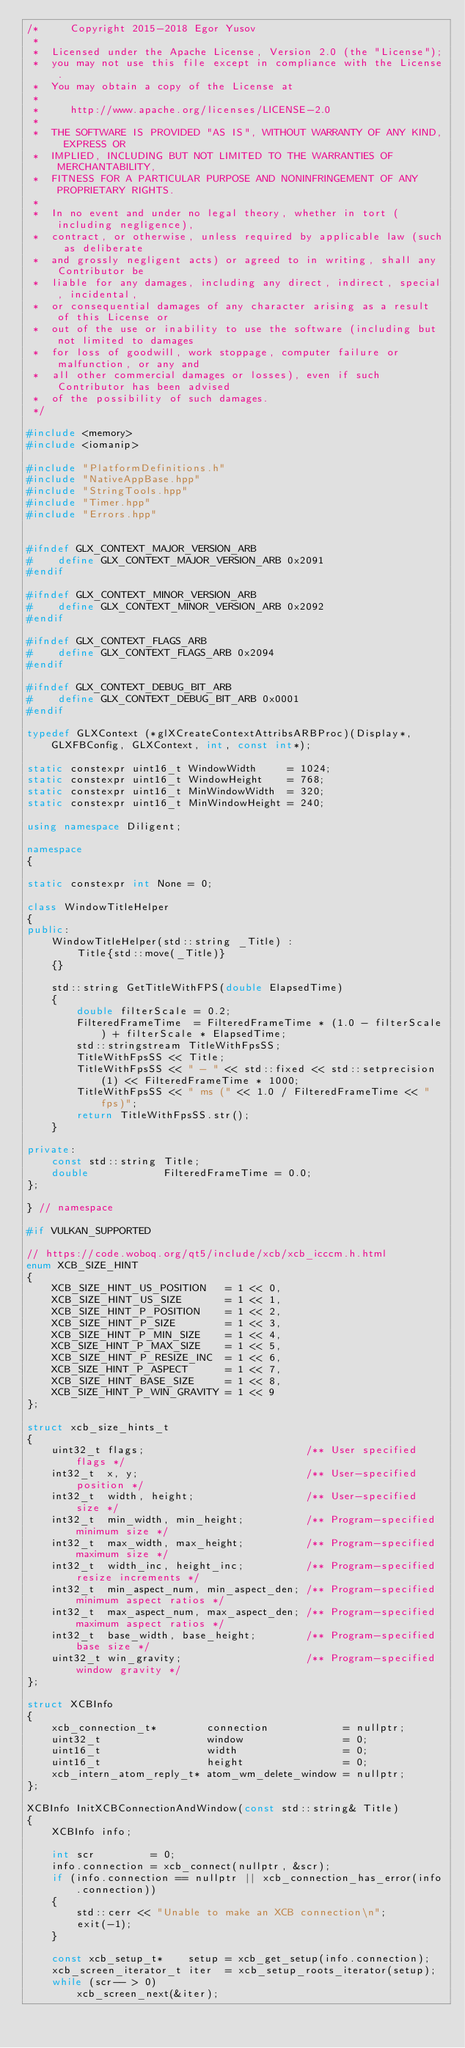Convert code to text. <code><loc_0><loc_0><loc_500><loc_500><_C++_>/*     Copyright 2015-2018 Egor Yusov
 *  
 *  Licensed under the Apache License, Version 2.0 (the "License");
 *  you may not use this file except in compliance with the License.
 *  You may obtain a copy of the License at
 * 
 *     http://www.apache.org/licenses/LICENSE-2.0
 * 
 *  THE SOFTWARE IS PROVIDED "AS IS", WITHOUT WARRANTY OF ANY KIND, EXPRESS OR
 *  IMPLIED, INCLUDING BUT NOT LIMITED TO THE WARRANTIES OF MERCHANTABILITY,
 *  FITNESS FOR A PARTICULAR PURPOSE AND NONINFRINGEMENT OF ANY PROPRIETARY RIGHTS.
 *
 *  In no event and under no legal theory, whether in tort (including negligence), 
 *  contract, or otherwise, unless required by applicable law (such as deliberate 
 *  and grossly negligent acts) or agreed to in writing, shall any Contributor be
 *  liable for any damages, including any direct, indirect, special, incidental, 
 *  or consequential damages of any character arising as a result of this License or 
 *  out of the use or inability to use the software (including but not limited to damages 
 *  for loss of goodwill, work stoppage, computer failure or malfunction, or any and 
 *  all other commercial damages or losses), even if such Contributor has been advised 
 *  of the possibility of such damages.
 */

#include <memory>
#include <iomanip>

#include "PlatformDefinitions.h"
#include "NativeAppBase.hpp"
#include "StringTools.hpp"
#include "Timer.hpp"
#include "Errors.hpp"


#ifndef GLX_CONTEXT_MAJOR_VERSION_ARB
#    define GLX_CONTEXT_MAJOR_VERSION_ARB 0x2091
#endif

#ifndef GLX_CONTEXT_MINOR_VERSION_ARB
#    define GLX_CONTEXT_MINOR_VERSION_ARB 0x2092
#endif

#ifndef GLX_CONTEXT_FLAGS_ARB
#    define GLX_CONTEXT_FLAGS_ARB 0x2094
#endif

#ifndef GLX_CONTEXT_DEBUG_BIT_ARB
#    define GLX_CONTEXT_DEBUG_BIT_ARB 0x0001
#endif

typedef GLXContext (*glXCreateContextAttribsARBProc)(Display*, GLXFBConfig, GLXContext, int, const int*);

static constexpr uint16_t WindowWidth     = 1024;
static constexpr uint16_t WindowHeight    = 768;
static constexpr uint16_t MinWindowWidth  = 320;
static constexpr uint16_t MinWindowHeight = 240;

using namespace Diligent;

namespace
{

static constexpr int None = 0;

class WindowTitleHelper
{
public:
    WindowTitleHelper(std::string _Title) :
        Title{std::move(_Title)}
    {}

    std::string GetTitleWithFPS(double ElapsedTime)
    {
        double filterScale = 0.2;
        FilteredFrameTime  = FilteredFrameTime * (1.0 - filterScale) + filterScale * ElapsedTime;
        std::stringstream TitleWithFpsSS;
        TitleWithFpsSS << Title;
        TitleWithFpsSS << " - " << std::fixed << std::setprecision(1) << FilteredFrameTime * 1000;
        TitleWithFpsSS << " ms (" << 1.0 / FilteredFrameTime << " fps)";
        return TitleWithFpsSS.str();
    }

private:
    const std::string Title;
    double            FilteredFrameTime = 0.0;
};

} // namespace

#if VULKAN_SUPPORTED

// https://code.woboq.org/qt5/include/xcb/xcb_icccm.h.html
enum XCB_SIZE_HINT
{
    XCB_SIZE_HINT_US_POSITION   = 1 << 0,
    XCB_SIZE_HINT_US_SIZE       = 1 << 1,
    XCB_SIZE_HINT_P_POSITION    = 1 << 2,
    XCB_SIZE_HINT_P_SIZE        = 1 << 3,
    XCB_SIZE_HINT_P_MIN_SIZE    = 1 << 4,
    XCB_SIZE_HINT_P_MAX_SIZE    = 1 << 5,
    XCB_SIZE_HINT_P_RESIZE_INC  = 1 << 6,
    XCB_SIZE_HINT_P_ASPECT      = 1 << 7,
    XCB_SIZE_HINT_BASE_SIZE     = 1 << 8,
    XCB_SIZE_HINT_P_WIN_GRAVITY = 1 << 9
};

struct xcb_size_hints_t
{
    uint32_t flags;                          /** User specified flags */
    int32_t  x, y;                           /** User-specified position */
    int32_t  width, height;                  /** User-specified size */
    int32_t  min_width, min_height;          /** Program-specified minimum size */
    int32_t  max_width, max_height;          /** Program-specified maximum size */
    int32_t  width_inc, height_inc;          /** Program-specified resize increments */
    int32_t  min_aspect_num, min_aspect_den; /** Program-specified minimum aspect ratios */
    int32_t  max_aspect_num, max_aspect_den; /** Program-specified maximum aspect ratios */
    int32_t  base_width, base_height;        /** Program-specified base size */
    uint32_t win_gravity;                    /** Program-specified window gravity */
};

struct XCBInfo
{
    xcb_connection_t*        connection            = nullptr;
    uint32_t                 window                = 0;
    uint16_t                 width                 = 0;
    uint16_t                 height                = 0;
    xcb_intern_atom_reply_t* atom_wm_delete_window = nullptr;
};

XCBInfo InitXCBConnectionAndWindow(const std::string& Title)
{
    XCBInfo info;

    int scr         = 0;
    info.connection = xcb_connect(nullptr, &scr);
    if (info.connection == nullptr || xcb_connection_has_error(info.connection))
    {
        std::cerr << "Unable to make an XCB connection\n";
        exit(-1);
    }

    const xcb_setup_t*    setup = xcb_get_setup(info.connection);
    xcb_screen_iterator_t iter  = xcb_setup_roots_iterator(setup);
    while (scr-- > 0)
        xcb_screen_next(&iter);
</code> 